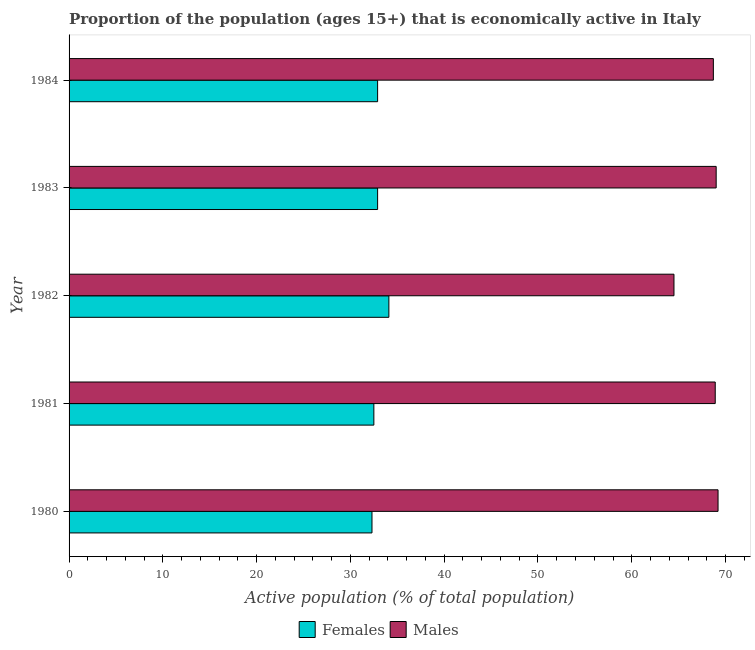How many different coloured bars are there?
Make the answer very short. 2. How many groups of bars are there?
Your answer should be compact. 5. Are the number of bars on each tick of the Y-axis equal?
Your answer should be compact. Yes. How many bars are there on the 1st tick from the bottom?
Offer a terse response. 2. What is the percentage of economically active female population in 1980?
Your answer should be very brief. 32.3. Across all years, what is the maximum percentage of economically active female population?
Ensure brevity in your answer.  34.1. Across all years, what is the minimum percentage of economically active male population?
Ensure brevity in your answer.  64.5. What is the total percentage of economically active male population in the graph?
Provide a short and direct response. 340.3. What is the difference between the percentage of economically active male population in 1981 and the percentage of economically active female population in 1980?
Your response must be concise. 36.6. What is the average percentage of economically active male population per year?
Your response must be concise. 68.06. In the year 1983, what is the difference between the percentage of economically active male population and percentage of economically active female population?
Keep it short and to the point. 36.1. What is the ratio of the percentage of economically active female population in 1982 to that in 1983?
Your answer should be compact. 1.04. Is the percentage of economically active female population in 1983 less than that in 1984?
Offer a very short reply. No. Is the difference between the percentage of economically active male population in 1980 and 1984 greater than the difference between the percentage of economically active female population in 1980 and 1984?
Provide a short and direct response. Yes. What is the difference between the highest and the second highest percentage of economically active female population?
Give a very brief answer. 1.2. Is the sum of the percentage of economically active female population in 1980 and 1982 greater than the maximum percentage of economically active male population across all years?
Give a very brief answer. No. What does the 1st bar from the top in 1982 represents?
Keep it short and to the point. Males. What does the 2nd bar from the bottom in 1980 represents?
Provide a succinct answer. Males. How many years are there in the graph?
Provide a succinct answer. 5. Are the values on the major ticks of X-axis written in scientific E-notation?
Keep it short and to the point. No. Does the graph contain grids?
Ensure brevity in your answer.  No. What is the title of the graph?
Offer a very short reply. Proportion of the population (ages 15+) that is economically active in Italy. Does "Start a business" appear as one of the legend labels in the graph?
Offer a very short reply. No. What is the label or title of the X-axis?
Offer a very short reply. Active population (% of total population). What is the Active population (% of total population) of Females in 1980?
Provide a succinct answer. 32.3. What is the Active population (% of total population) in Males in 1980?
Give a very brief answer. 69.2. What is the Active population (% of total population) in Females in 1981?
Your answer should be very brief. 32.5. What is the Active population (% of total population) in Males in 1981?
Your answer should be very brief. 68.9. What is the Active population (% of total population) of Females in 1982?
Give a very brief answer. 34.1. What is the Active population (% of total population) of Males in 1982?
Keep it short and to the point. 64.5. What is the Active population (% of total population) of Females in 1983?
Your response must be concise. 32.9. What is the Active population (% of total population) of Females in 1984?
Your response must be concise. 32.9. What is the Active population (% of total population) of Males in 1984?
Ensure brevity in your answer.  68.7. Across all years, what is the maximum Active population (% of total population) of Females?
Ensure brevity in your answer.  34.1. Across all years, what is the maximum Active population (% of total population) of Males?
Ensure brevity in your answer.  69.2. Across all years, what is the minimum Active population (% of total population) in Females?
Your answer should be compact. 32.3. Across all years, what is the minimum Active population (% of total population) of Males?
Ensure brevity in your answer.  64.5. What is the total Active population (% of total population) in Females in the graph?
Your answer should be compact. 164.7. What is the total Active population (% of total population) of Males in the graph?
Offer a terse response. 340.3. What is the difference between the Active population (% of total population) in Males in 1980 and that in 1981?
Keep it short and to the point. 0.3. What is the difference between the Active population (% of total population) of Males in 1980 and that in 1982?
Keep it short and to the point. 4.7. What is the difference between the Active population (% of total population) of Males in 1980 and that in 1984?
Make the answer very short. 0.5. What is the difference between the Active population (% of total population) of Males in 1981 and that in 1982?
Ensure brevity in your answer.  4.4. What is the difference between the Active population (% of total population) in Males in 1981 and that in 1984?
Provide a succinct answer. 0.2. What is the difference between the Active population (% of total population) of Males in 1982 and that in 1983?
Your response must be concise. -4.5. What is the difference between the Active population (% of total population) of Females in 1982 and that in 1984?
Your answer should be compact. 1.2. What is the difference between the Active population (% of total population) of Males in 1983 and that in 1984?
Keep it short and to the point. 0.3. What is the difference between the Active population (% of total population) of Females in 1980 and the Active population (% of total population) of Males in 1981?
Keep it short and to the point. -36.6. What is the difference between the Active population (% of total population) in Females in 1980 and the Active population (% of total population) in Males in 1982?
Ensure brevity in your answer.  -32.2. What is the difference between the Active population (% of total population) in Females in 1980 and the Active population (% of total population) in Males in 1983?
Your response must be concise. -36.7. What is the difference between the Active population (% of total population) in Females in 1980 and the Active population (% of total population) in Males in 1984?
Your response must be concise. -36.4. What is the difference between the Active population (% of total population) of Females in 1981 and the Active population (% of total population) of Males in 1982?
Keep it short and to the point. -32. What is the difference between the Active population (% of total population) in Females in 1981 and the Active population (% of total population) in Males in 1983?
Ensure brevity in your answer.  -36.5. What is the difference between the Active population (% of total population) of Females in 1981 and the Active population (% of total population) of Males in 1984?
Keep it short and to the point. -36.2. What is the difference between the Active population (% of total population) of Females in 1982 and the Active population (% of total population) of Males in 1983?
Your response must be concise. -34.9. What is the difference between the Active population (% of total population) of Females in 1982 and the Active population (% of total population) of Males in 1984?
Your answer should be very brief. -34.6. What is the difference between the Active population (% of total population) in Females in 1983 and the Active population (% of total population) in Males in 1984?
Ensure brevity in your answer.  -35.8. What is the average Active population (% of total population) in Females per year?
Provide a succinct answer. 32.94. What is the average Active population (% of total population) of Males per year?
Your answer should be compact. 68.06. In the year 1980, what is the difference between the Active population (% of total population) in Females and Active population (% of total population) in Males?
Offer a terse response. -36.9. In the year 1981, what is the difference between the Active population (% of total population) in Females and Active population (% of total population) in Males?
Your response must be concise. -36.4. In the year 1982, what is the difference between the Active population (% of total population) in Females and Active population (% of total population) in Males?
Make the answer very short. -30.4. In the year 1983, what is the difference between the Active population (% of total population) in Females and Active population (% of total population) in Males?
Provide a succinct answer. -36.1. In the year 1984, what is the difference between the Active population (% of total population) of Females and Active population (% of total population) of Males?
Ensure brevity in your answer.  -35.8. What is the ratio of the Active population (% of total population) in Females in 1980 to that in 1982?
Provide a succinct answer. 0.95. What is the ratio of the Active population (% of total population) of Males in 1980 to that in 1982?
Give a very brief answer. 1.07. What is the ratio of the Active population (% of total population) of Females in 1980 to that in 1983?
Offer a very short reply. 0.98. What is the ratio of the Active population (% of total population) in Males in 1980 to that in 1983?
Offer a very short reply. 1. What is the ratio of the Active population (% of total population) of Females in 1980 to that in 1984?
Offer a terse response. 0.98. What is the ratio of the Active population (% of total population) of Males in 1980 to that in 1984?
Make the answer very short. 1.01. What is the ratio of the Active population (% of total population) in Females in 1981 to that in 1982?
Offer a very short reply. 0.95. What is the ratio of the Active population (% of total population) of Males in 1981 to that in 1982?
Give a very brief answer. 1.07. What is the ratio of the Active population (% of total population) of Males in 1981 to that in 1983?
Your answer should be compact. 1. What is the ratio of the Active population (% of total population) of Males in 1981 to that in 1984?
Offer a terse response. 1. What is the ratio of the Active population (% of total population) of Females in 1982 to that in 1983?
Your response must be concise. 1.04. What is the ratio of the Active population (% of total population) of Males in 1982 to that in 1983?
Keep it short and to the point. 0.93. What is the ratio of the Active population (% of total population) of Females in 1982 to that in 1984?
Offer a terse response. 1.04. What is the ratio of the Active population (% of total population) of Males in 1982 to that in 1984?
Keep it short and to the point. 0.94. What is the ratio of the Active population (% of total population) of Females in 1983 to that in 1984?
Keep it short and to the point. 1. What is the difference between the highest and the second highest Active population (% of total population) in Females?
Provide a short and direct response. 1.2. 